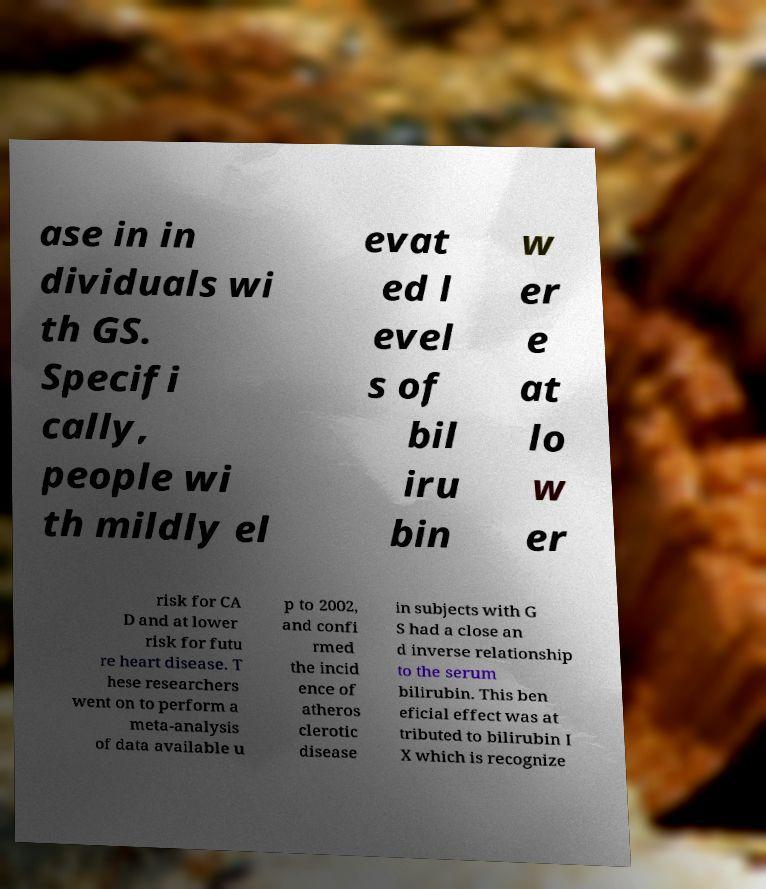Please identify and transcribe the text found in this image. ase in in dividuals wi th GS. Specifi cally, people wi th mildly el evat ed l evel s of bil iru bin w er e at lo w er risk for CA D and at lower risk for futu re heart disease. T hese researchers went on to perform a meta-analysis of data available u p to 2002, and confi rmed the incid ence of atheros clerotic disease in subjects with G S had a close an d inverse relationship to the serum bilirubin. This ben eficial effect was at tributed to bilirubin I X which is recognize 